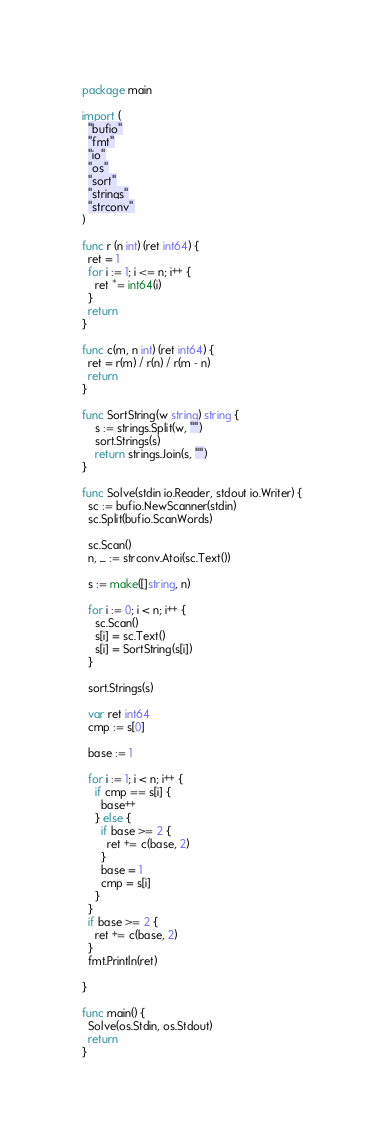Convert code to text. <code><loc_0><loc_0><loc_500><loc_500><_Go_>package main

import (
  "bufio"
  "fmt"
  "io"
  "os"
  "sort"
  "strings"
  "strconv"
)

func r (n int) (ret int64) {
  ret = 1
  for i := 1; i <= n; i++ {
    ret *= int64(i)
  }
  return
}

func c(m, n int) (ret int64) {
  ret = r(m) / r(n) / r(m - n)
  return
}

func SortString(w string) string {
    s := strings.Split(w, "")
    sort.Strings(s)
    return strings.Join(s, "")
}

func Solve(stdin io.Reader, stdout io.Writer) {
  sc := bufio.NewScanner(stdin)
  sc.Split(bufio.ScanWords)

  sc.Scan()
  n, _ := strconv.Atoi(sc.Text())

  s := make([]string, n)

  for i := 0; i < n; i++ {
    sc.Scan()
    s[i] = sc.Text()
    s[i] = SortString(s[i])
  }

  sort.Strings(s)

  var ret int64
  cmp := s[0]

  base := 1

  for i := 1; i < n; i++ {
    if cmp == s[i] {
      base++
    } else {
      if base >= 2 {
        ret += c(base, 2)
      }
      base = 1
      cmp = s[i]
    }
  }
  if base >= 2 {
    ret += c(base, 2)
  }
  fmt.Println(ret)

}

func main() {
  Solve(os.Stdin, os.Stdout)
  return
}
</code> 